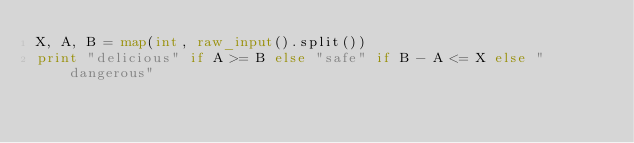<code> <loc_0><loc_0><loc_500><loc_500><_Python_>X, A, B = map(int, raw_input().split())
print "delicious" if A >= B else "safe" if B - A <= X else "dangerous"
</code> 